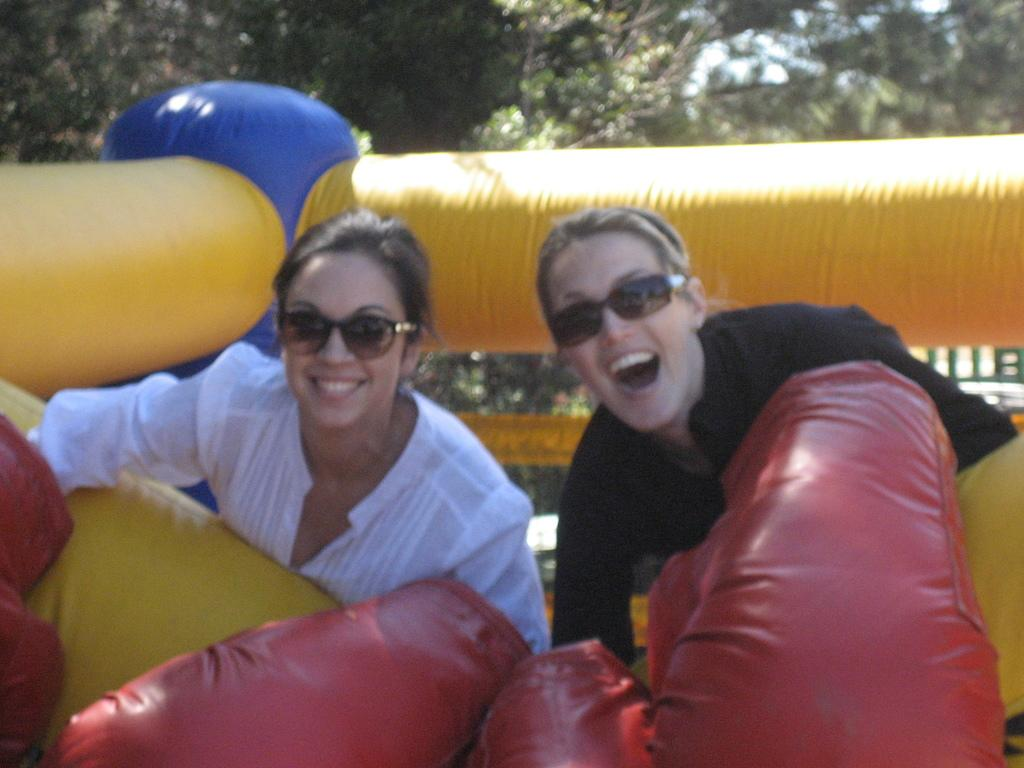How many people are in the image? There are two persons in the image. What are the persons doing in the image? The persons are smiling. What are the persons wearing on their faces? The persons are wearing goggles. What can be seen in the front of the image? There is an inflatable in the front of the image. What type of natural scenery is visible in the background? There are trees in the background of the image. What type of beds can be seen in the image? There are no beds present in the image. How do the persons react to the inflatable in the image? The image does not show a reaction from the persons; it only shows them smiling and wearing goggles. 